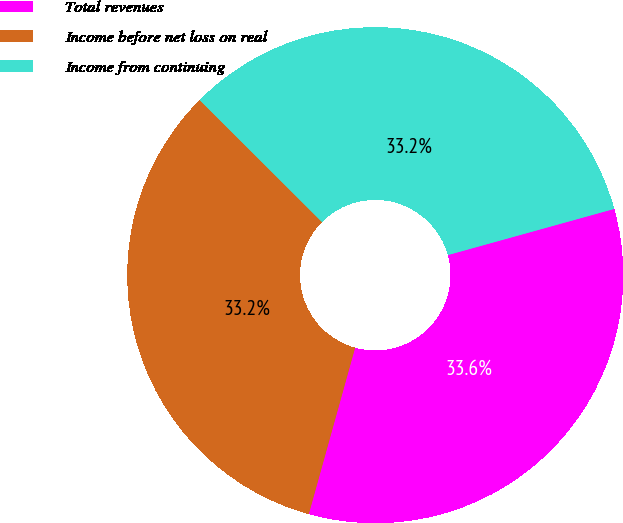<chart> <loc_0><loc_0><loc_500><loc_500><pie_chart><fcel>Total revenues<fcel>Income before net loss on real<fcel>Income from continuing<nl><fcel>33.63%<fcel>33.16%<fcel>33.21%<nl></chart> 